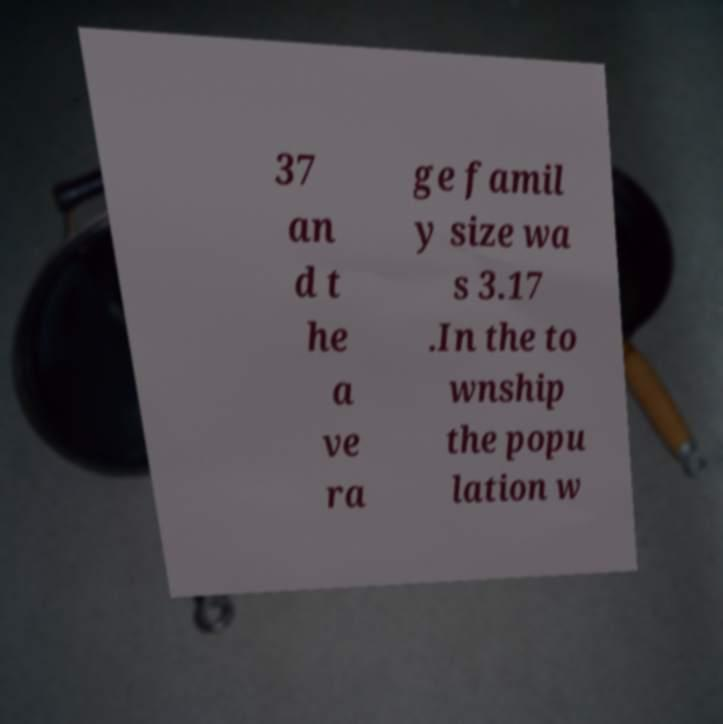Can you accurately transcribe the text from the provided image for me? 37 an d t he a ve ra ge famil y size wa s 3.17 .In the to wnship the popu lation w 